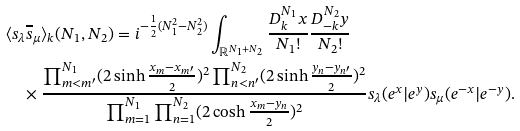<formula> <loc_0><loc_0><loc_500><loc_500>& \langle s _ { \lambda } \overline { s } _ { \mu } \rangle _ { k } ( N _ { 1 } , N _ { 2 } ) = i ^ { - \frac { 1 } { 2 } ( N _ { 1 } ^ { 2 } - N _ { 2 } ^ { 2 } ) } \int _ { { \mathbb { R } } ^ { N _ { 1 } + N _ { 2 } } } \frac { D _ { k } ^ { N _ { 1 } } x } { N _ { 1 } ! } \frac { D _ { - k } ^ { N _ { 2 } } y } { N _ { 2 } ! } \\ & \quad \times \frac { \prod _ { m < m ^ { \prime } } ^ { N _ { 1 } } ( 2 \sinh \frac { x _ { m } - x _ { m ^ { \prime } } } { 2 } ) ^ { 2 } \prod _ { n < n ^ { \prime } } ^ { N _ { 2 } } ( 2 \sinh \frac { y _ { n } - y _ { n ^ { \prime } } } { 2 } ) ^ { 2 } } { \prod _ { m = 1 } ^ { N _ { 1 } } \prod _ { n = 1 } ^ { N _ { 2 } } ( 2 \cosh \frac { x _ { m } - y _ { n } } { 2 } ) ^ { 2 } } s _ { \lambda } ( e ^ { x } | e ^ { y } ) s _ { \mu } ( e ^ { - x } | e ^ { - y } ) .</formula> 